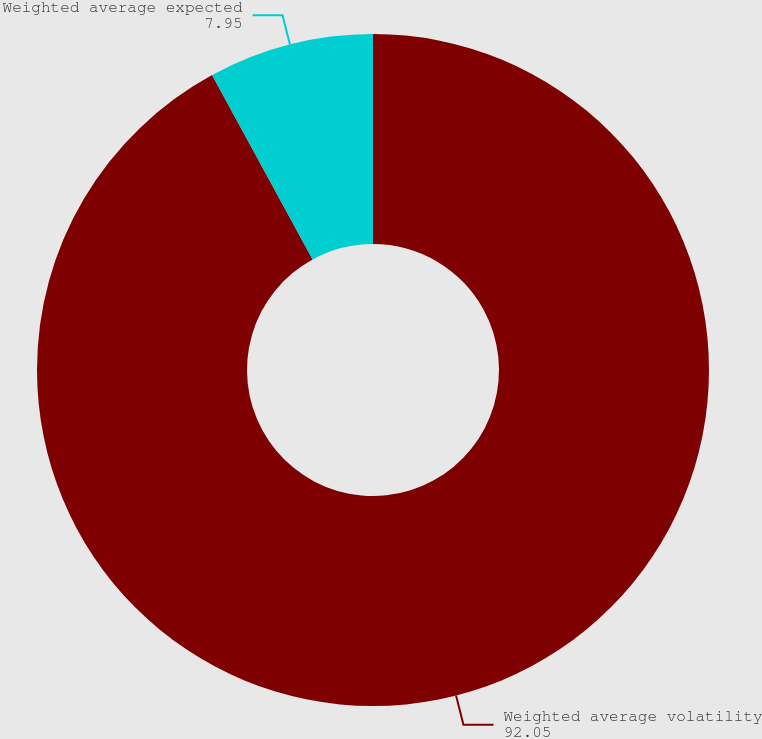Convert chart. <chart><loc_0><loc_0><loc_500><loc_500><pie_chart><fcel>Weighted average volatility<fcel>Weighted average expected<nl><fcel>92.05%<fcel>7.95%<nl></chart> 